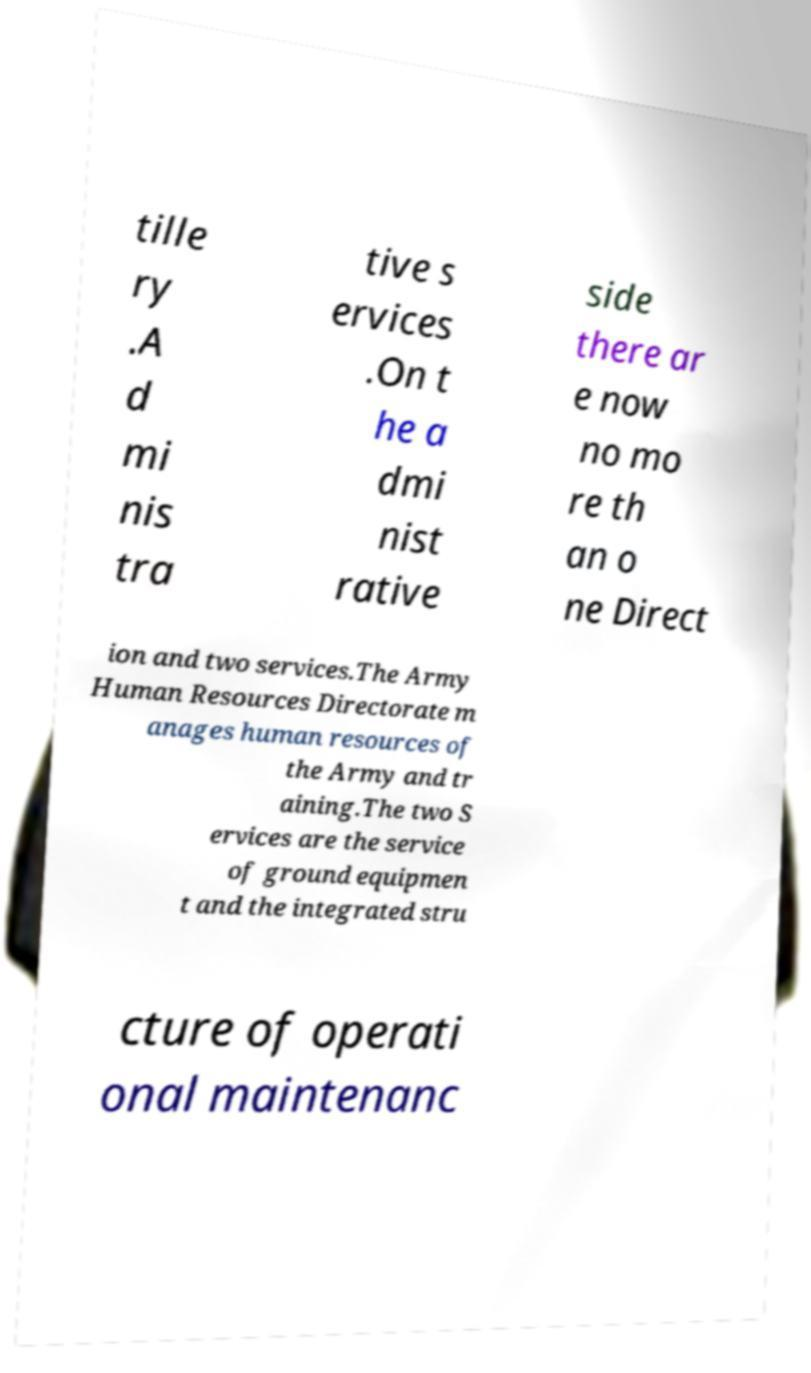Could you extract and type out the text from this image? tille ry .A d mi nis tra tive s ervices .On t he a dmi nist rative side there ar e now no mo re th an o ne Direct ion and two services.The Army Human Resources Directorate m anages human resources of the Army and tr aining.The two S ervices are the service of ground equipmen t and the integrated stru cture of operati onal maintenanc 